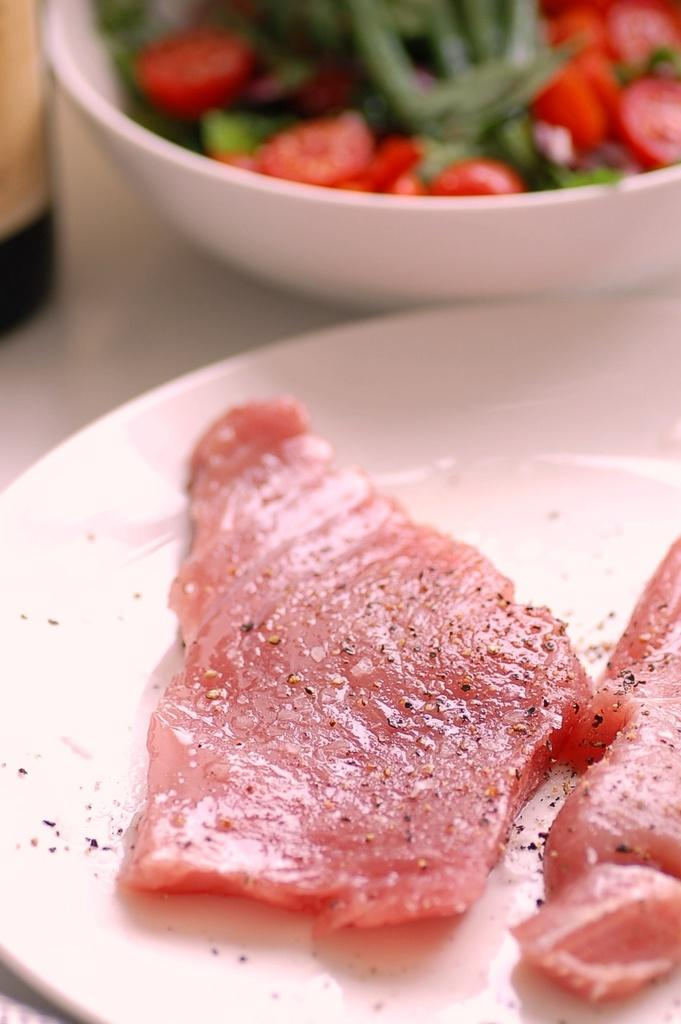What is the main food item visible in the image? There is a food item on a white plate and in a white bowl in the image. Where is the white plate located in the image? The white plate is at the bottom of the image. Where is the white bowl located in the image? The white bowl is at the top of the image. What type of sweater is the rat wearing in the image? There is no rat or sweater present in the image. 